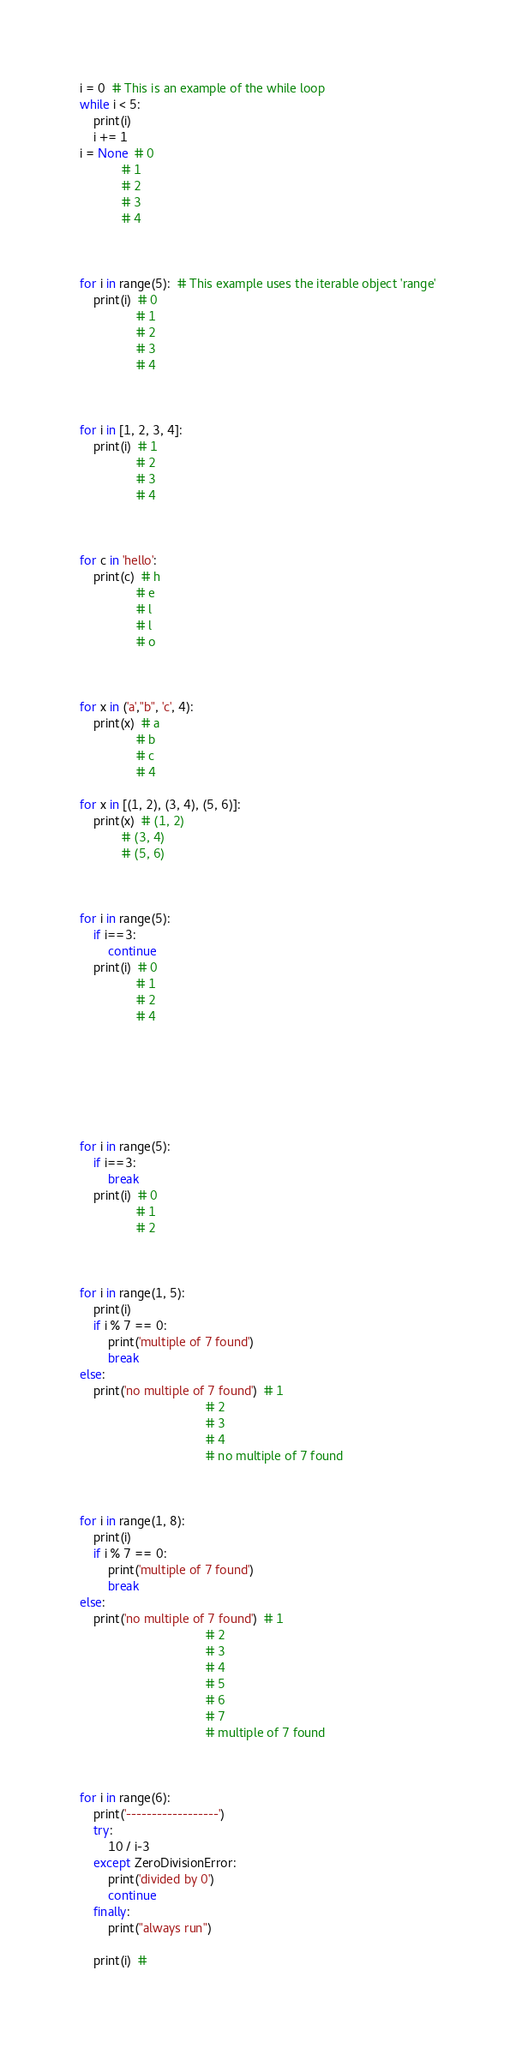<code> <loc_0><loc_0><loc_500><loc_500><_Python_>i = 0  # This is an example of the while loop
while i < 5:
    print(i)
    i += 1
i = None  # 0
            # 1
            # 2
            # 3
            # 4



for i in range(5):  # This example uses the iterable object 'range'
    print(i)  # 0
                # 1
                # 2
                # 3
                # 4



for i in [1, 2, 3, 4]:
    print(i)  # 1
                # 2
                # 3
                # 4



for c in 'hello':
    print(c)  # h
                # e
                # l
                # l
                # o



for x in ('a',"b", 'c', 4):
    print(x)  # a
                # b
                # c
                # 4

for x in [(1, 2), (3, 4), (5, 6)]:
    print(x)  # (1, 2)
            # (3, 4)
            # (5, 6)



for i in range(5):
    if i==3:
        continue
    print(i)  # 0
                # 1
                # 2
                # 4







for i in range(5):
    if i==3:
        break
    print(i)  # 0
                # 1
                # 2



for i in range(1, 5):
    print(i)
    if i % 7 == 0:
        print('multiple of 7 found')
        break
else:
    print('no multiple of 7 found')  # 1
                                    # 2
                                    # 3
                                    # 4
                                    # no multiple of 7 found



for i in range(1, 8):
    print(i)
    if i % 7 == 0:
        print('multiple of 7 found')
        break
else:
    print('no multiple of 7 found')  # 1
                                    # 2
                                    # 3
                                    # 4
                                    # 5
                                    # 6
                                    # 7
                                    # multiple of 7 found



for i in range(6):
    print('------------------')
    try:
        10 / i-3
    except ZeroDivisionError:
        print('divided by 0')
        continue
    finally:
        print("always run")

    print(i)  # 
</code> 